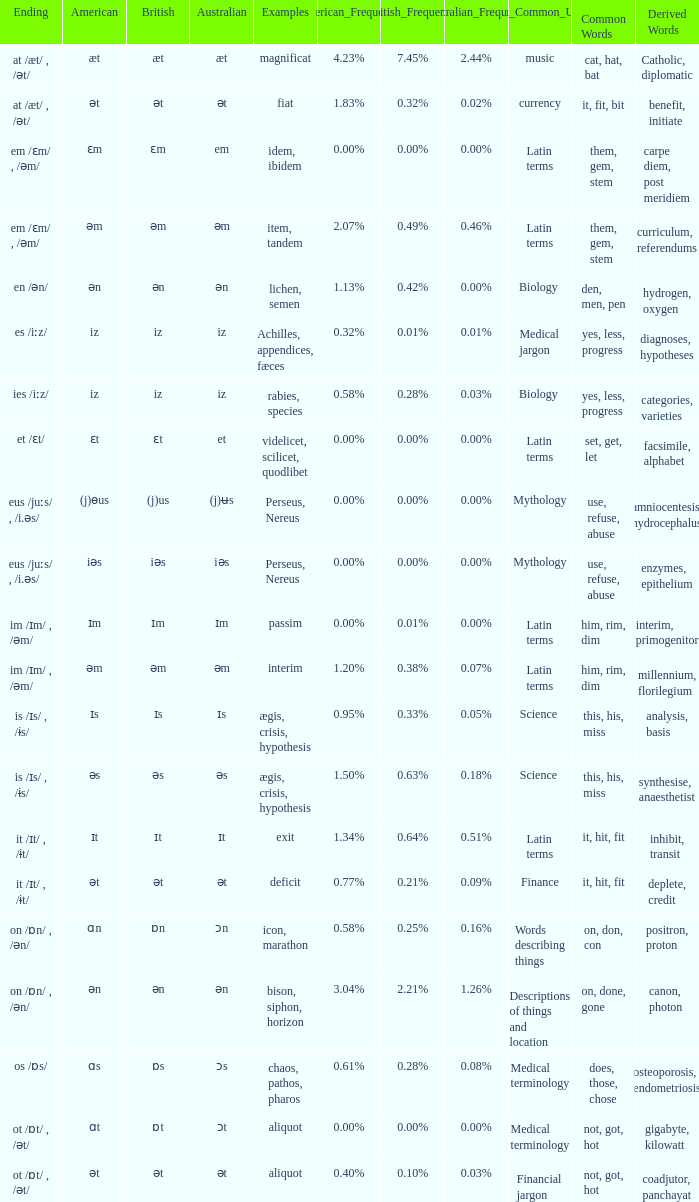Which Ending has British of iz, and Examples of achilles, appendices, fæces? Es /iːz/. 